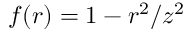Convert formula to latex. <formula><loc_0><loc_0><loc_500><loc_500>f ( r ) = 1 - r ^ { 2 } / z ^ { 2 }</formula> 